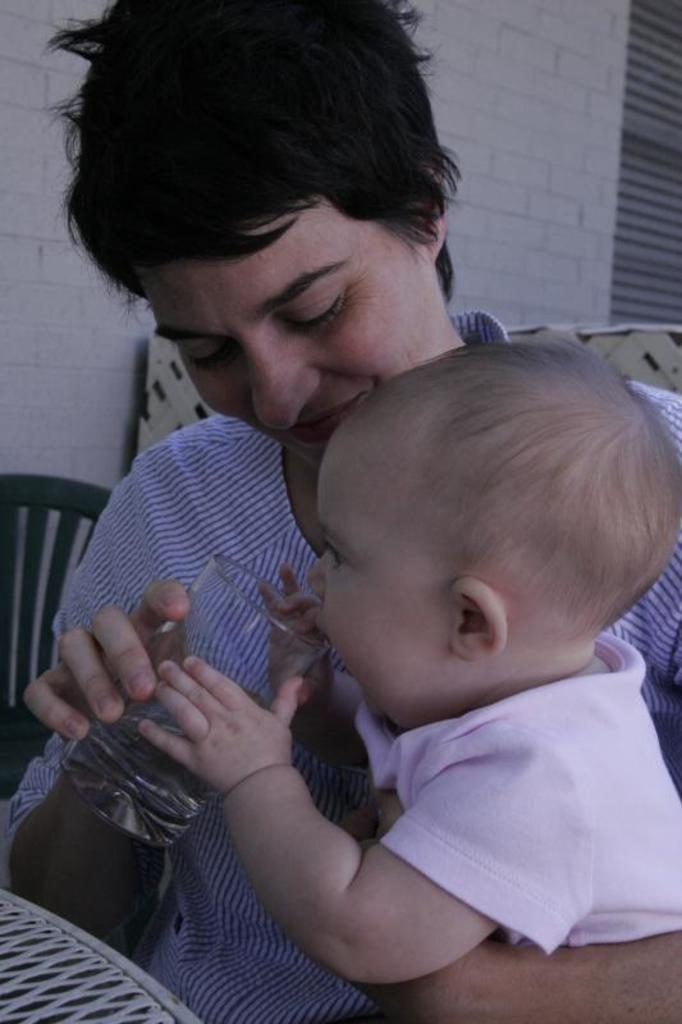Who is the main subject in the image? There is a woman in the image. What is the woman doing in the image? The woman is feeding a baby. What can be seen on the table in the image? There is a glass of water in front of the table. What type of furniture is visible in the background of the image? There is a chair beside the wall in the background. What type of lettuce is being used to feed the baby in the image? There is no lettuce present in the image; the woman is feeding the baby, but the food is not specified. 